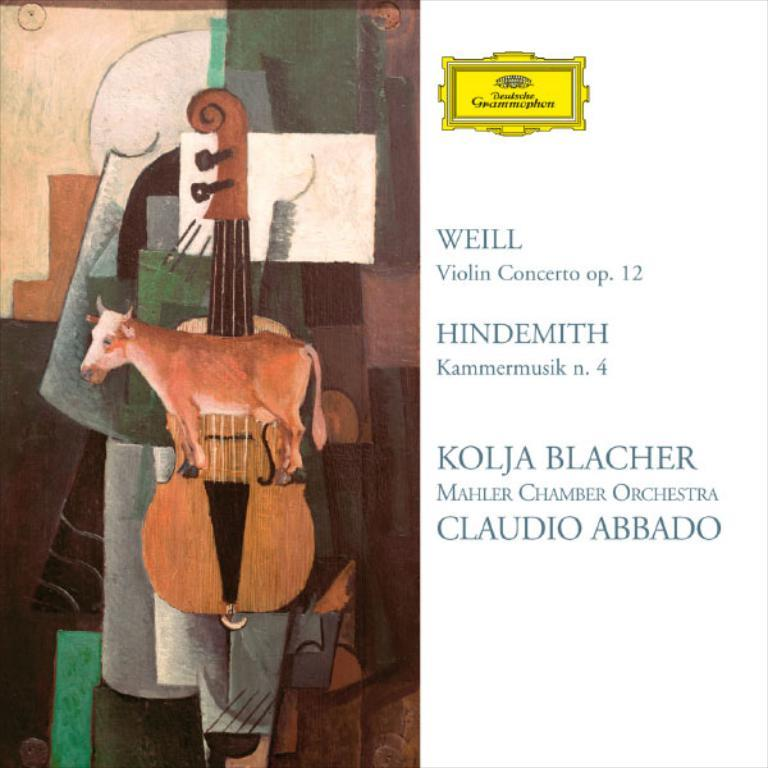What is depicted on the left side of the image? There is a depiction of an animal and a guitar on the left side of the image. What else can be seen on the left side of the image? There is a board and other objects on the left side of the image. What is present on the right side of the image? There is text on the right side of the image. Can you see a crown on the animal's head in the image? There is no crown visible on the animal's head in the image. Is there any thread being used in the image? There is no thread present in the image. 